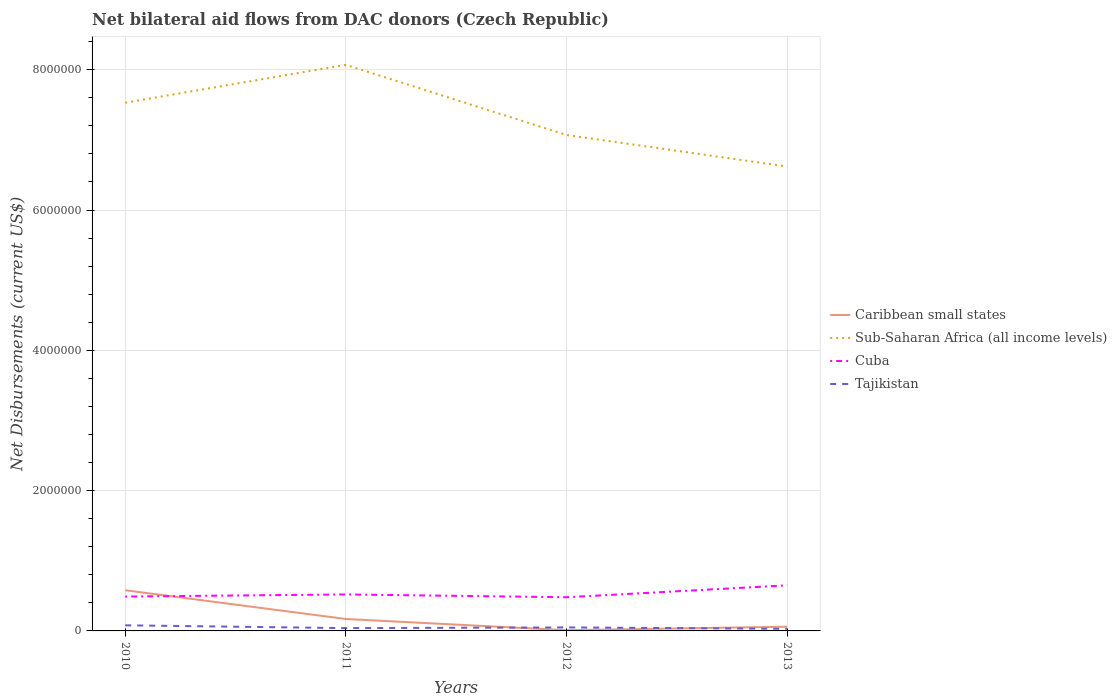Does the line corresponding to Sub-Saharan Africa (all income levels) intersect with the line corresponding to Cuba?
Provide a succinct answer. No. Is the number of lines equal to the number of legend labels?
Give a very brief answer. Yes. Across all years, what is the maximum net bilateral aid flows in Cuba?
Your answer should be very brief. 4.80e+05. What is the total net bilateral aid flows in Cuba in the graph?
Provide a short and direct response. -1.30e+05. What is the difference between the highest and the second highest net bilateral aid flows in Cuba?
Your response must be concise. 1.70e+05. Is the net bilateral aid flows in Cuba strictly greater than the net bilateral aid flows in Sub-Saharan Africa (all income levels) over the years?
Offer a terse response. Yes. Does the graph contain any zero values?
Keep it short and to the point. No. How are the legend labels stacked?
Make the answer very short. Vertical. What is the title of the graph?
Offer a very short reply. Net bilateral aid flows from DAC donors (Czech Republic). What is the label or title of the Y-axis?
Make the answer very short. Net Disbursements (current US$). What is the Net Disbursements (current US$) of Caribbean small states in 2010?
Keep it short and to the point. 5.80e+05. What is the Net Disbursements (current US$) of Sub-Saharan Africa (all income levels) in 2010?
Your response must be concise. 7.53e+06. What is the Net Disbursements (current US$) in Tajikistan in 2010?
Give a very brief answer. 8.00e+04. What is the Net Disbursements (current US$) in Caribbean small states in 2011?
Give a very brief answer. 1.70e+05. What is the Net Disbursements (current US$) of Sub-Saharan Africa (all income levels) in 2011?
Ensure brevity in your answer.  8.07e+06. What is the Net Disbursements (current US$) in Cuba in 2011?
Offer a terse response. 5.20e+05. What is the Net Disbursements (current US$) in Sub-Saharan Africa (all income levels) in 2012?
Offer a terse response. 7.07e+06. What is the Net Disbursements (current US$) in Cuba in 2012?
Provide a short and direct response. 4.80e+05. What is the Net Disbursements (current US$) in Tajikistan in 2012?
Give a very brief answer. 5.00e+04. What is the Net Disbursements (current US$) of Sub-Saharan Africa (all income levels) in 2013?
Provide a short and direct response. 6.62e+06. What is the Net Disbursements (current US$) of Cuba in 2013?
Give a very brief answer. 6.50e+05. What is the Net Disbursements (current US$) of Tajikistan in 2013?
Make the answer very short. 3.00e+04. Across all years, what is the maximum Net Disbursements (current US$) in Caribbean small states?
Make the answer very short. 5.80e+05. Across all years, what is the maximum Net Disbursements (current US$) in Sub-Saharan Africa (all income levels)?
Offer a very short reply. 8.07e+06. Across all years, what is the maximum Net Disbursements (current US$) of Cuba?
Offer a terse response. 6.50e+05. Across all years, what is the minimum Net Disbursements (current US$) in Sub-Saharan Africa (all income levels)?
Make the answer very short. 6.62e+06. What is the total Net Disbursements (current US$) of Caribbean small states in the graph?
Provide a short and direct response. 8.20e+05. What is the total Net Disbursements (current US$) of Sub-Saharan Africa (all income levels) in the graph?
Make the answer very short. 2.93e+07. What is the total Net Disbursements (current US$) of Cuba in the graph?
Your answer should be compact. 2.14e+06. What is the total Net Disbursements (current US$) in Tajikistan in the graph?
Your answer should be compact. 2.00e+05. What is the difference between the Net Disbursements (current US$) of Caribbean small states in 2010 and that in 2011?
Provide a short and direct response. 4.10e+05. What is the difference between the Net Disbursements (current US$) in Sub-Saharan Africa (all income levels) in 2010 and that in 2011?
Provide a short and direct response. -5.40e+05. What is the difference between the Net Disbursements (current US$) of Cuba in 2010 and that in 2011?
Offer a very short reply. -3.00e+04. What is the difference between the Net Disbursements (current US$) in Caribbean small states in 2010 and that in 2012?
Provide a short and direct response. 5.70e+05. What is the difference between the Net Disbursements (current US$) of Tajikistan in 2010 and that in 2012?
Your answer should be compact. 3.00e+04. What is the difference between the Net Disbursements (current US$) of Caribbean small states in 2010 and that in 2013?
Your answer should be very brief. 5.20e+05. What is the difference between the Net Disbursements (current US$) in Sub-Saharan Africa (all income levels) in 2010 and that in 2013?
Make the answer very short. 9.10e+05. What is the difference between the Net Disbursements (current US$) of Caribbean small states in 2011 and that in 2013?
Your answer should be compact. 1.10e+05. What is the difference between the Net Disbursements (current US$) of Sub-Saharan Africa (all income levels) in 2011 and that in 2013?
Offer a very short reply. 1.45e+06. What is the difference between the Net Disbursements (current US$) of Cuba in 2011 and that in 2013?
Give a very brief answer. -1.30e+05. What is the difference between the Net Disbursements (current US$) in Tajikistan in 2011 and that in 2013?
Your response must be concise. 10000. What is the difference between the Net Disbursements (current US$) of Caribbean small states in 2012 and that in 2013?
Provide a short and direct response. -5.00e+04. What is the difference between the Net Disbursements (current US$) in Sub-Saharan Africa (all income levels) in 2012 and that in 2013?
Ensure brevity in your answer.  4.50e+05. What is the difference between the Net Disbursements (current US$) in Cuba in 2012 and that in 2013?
Provide a short and direct response. -1.70e+05. What is the difference between the Net Disbursements (current US$) in Tajikistan in 2012 and that in 2013?
Provide a succinct answer. 2.00e+04. What is the difference between the Net Disbursements (current US$) of Caribbean small states in 2010 and the Net Disbursements (current US$) of Sub-Saharan Africa (all income levels) in 2011?
Ensure brevity in your answer.  -7.49e+06. What is the difference between the Net Disbursements (current US$) of Caribbean small states in 2010 and the Net Disbursements (current US$) of Cuba in 2011?
Your answer should be compact. 6.00e+04. What is the difference between the Net Disbursements (current US$) in Caribbean small states in 2010 and the Net Disbursements (current US$) in Tajikistan in 2011?
Ensure brevity in your answer.  5.40e+05. What is the difference between the Net Disbursements (current US$) of Sub-Saharan Africa (all income levels) in 2010 and the Net Disbursements (current US$) of Cuba in 2011?
Offer a terse response. 7.01e+06. What is the difference between the Net Disbursements (current US$) in Sub-Saharan Africa (all income levels) in 2010 and the Net Disbursements (current US$) in Tajikistan in 2011?
Provide a short and direct response. 7.49e+06. What is the difference between the Net Disbursements (current US$) of Caribbean small states in 2010 and the Net Disbursements (current US$) of Sub-Saharan Africa (all income levels) in 2012?
Offer a terse response. -6.49e+06. What is the difference between the Net Disbursements (current US$) in Caribbean small states in 2010 and the Net Disbursements (current US$) in Cuba in 2012?
Make the answer very short. 1.00e+05. What is the difference between the Net Disbursements (current US$) of Caribbean small states in 2010 and the Net Disbursements (current US$) of Tajikistan in 2012?
Your answer should be very brief. 5.30e+05. What is the difference between the Net Disbursements (current US$) of Sub-Saharan Africa (all income levels) in 2010 and the Net Disbursements (current US$) of Cuba in 2012?
Keep it short and to the point. 7.05e+06. What is the difference between the Net Disbursements (current US$) in Sub-Saharan Africa (all income levels) in 2010 and the Net Disbursements (current US$) in Tajikistan in 2012?
Give a very brief answer. 7.48e+06. What is the difference between the Net Disbursements (current US$) in Cuba in 2010 and the Net Disbursements (current US$) in Tajikistan in 2012?
Ensure brevity in your answer.  4.40e+05. What is the difference between the Net Disbursements (current US$) in Caribbean small states in 2010 and the Net Disbursements (current US$) in Sub-Saharan Africa (all income levels) in 2013?
Provide a short and direct response. -6.04e+06. What is the difference between the Net Disbursements (current US$) in Caribbean small states in 2010 and the Net Disbursements (current US$) in Cuba in 2013?
Your answer should be very brief. -7.00e+04. What is the difference between the Net Disbursements (current US$) of Sub-Saharan Africa (all income levels) in 2010 and the Net Disbursements (current US$) of Cuba in 2013?
Ensure brevity in your answer.  6.88e+06. What is the difference between the Net Disbursements (current US$) of Sub-Saharan Africa (all income levels) in 2010 and the Net Disbursements (current US$) of Tajikistan in 2013?
Make the answer very short. 7.50e+06. What is the difference between the Net Disbursements (current US$) in Caribbean small states in 2011 and the Net Disbursements (current US$) in Sub-Saharan Africa (all income levels) in 2012?
Your answer should be very brief. -6.90e+06. What is the difference between the Net Disbursements (current US$) of Caribbean small states in 2011 and the Net Disbursements (current US$) of Cuba in 2012?
Offer a very short reply. -3.10e+05. What is the difference between the Net Disbursements (current US$) of Caribbean small states in 2011 and the Net Disbursements (current US$) of Tajikistan in 2012?
Give a very brief answer. 1.20e+05. What is the difference between the Net Disbursements (current US$) in Sub-Saharan Africa (all income levels) in 2011 and the Net Disbursements (current US$) in Cuba in 2012?
Make the answer very short. 7.59e+06. What is the difference between the Net Disbursements (current US$) in Sub-Saharan Africa (all income levels) in 2011 and the Net Disbursements (current US$) in Tajikistan in 2012?
Offer a very short reply. 8.02e+06. What is the difference between the Net Disbursements (current US$) in Cuba in 2011 and the Net Disbursements (current US$) in Tajikistan in 2012?
Keep it short and to the point. 4.70e+05. What is the difference between the Net Disbursements (current US$) of Caribbean small states in 2011 and the Net Disbursements (current US$) of Sub-Saharan Africa (all income levels) in 2013?
Make the answer very short. -6.45e+06. What is the difference between the Net Disbursements (current US$) in Caribbean small states in 2011 and the Net Disbursements (current US$) in Cuba in 2013?
Make the answer very short. -4.80e+05. What is the difference between the Net Disbursements (current US$) of Sub-Saharan Africa (all income levels) in 2011 and the Net Disbursements (current US$) of Cuba in 2013?
Offer a terse response. 7.42e+06. What is the difference between the Net Disbursements (current US$) in Sub-Saharan Africa (all income levels) in 2011 and the Net Disbursements (current US$) in Tajikistan in 2013?
Ensure brevity in your answer.  8.04e+06. What is the difference between the Net Disbursements (current US$) in Cuba in 2011 and the Net Disbursements (current US$) in Tajikistan in 2013?
Offer a terse response. 4.90e+05. What is the difference between the Net Disbursements (current US$) of Caribbean small states in 2012 and the Net Disbursements (current US$) of Sub-Saharan Africa (all income levels) in 2013?
Provide a succinct answer. -6.61e+06. What is the difference between the Net Disbursements (current US$) in Caribbean small states in 2012 and the Net Disbursements (current US$) in Cuba in 2013?
Ensure brevity in your answer.  -6.40e+05. What is the difference between the Net Disbursements (current US$) in Caribbean small states in 2012 and the Net Disbursements (current US$) in Tajikistan in 2013?
Your answer should be very brief. -2.00e+04. What is the difference between the Net Disbursements (current US$) in Sub-Saharan Africa (all income levels) in 2012 and the Net Disbursements (current US$) in Cuba in 2013?
Keep it short and to the point. 6.42e+06. What is the difference between the Net Disbursements (current US$) of Sub-Saharan Africa (all income levels) in 2012 and the Net Disbursements (current US$) of Tajikistan in 2013?
Offer a terse response. 7.04e+06. What is the difference between the Net Disbursements (current US$) of Cuba in 2012 and the Net Disbursements (current US$) of Tajikistan in 2013?
Provide a short and direct response. 4.50e+05. What is the average Net Disbursements (current US$) in Caribbean small states per year?
Ensure brevity in your answer.  2.05e+05. What is the average Net Disbursements (current US$) of Sub-Saharan Africa (all income levels) per year?
Your answer should be compact. 7.32e+06. What is the average Net Disbursements (current US$) of Cuba per year?
Keep it short and to the point. 5.35e+05. In the year 2010, what is the difference between the Net Disbursements (current US$) of Caribbean small states and Net Disbursements (current US$) of Sub-Saharan Africa (all income levels)?
Your response must be concise. -6.95e+06. In the year 2010, what is the difference between the Net Disbursements (current US$) in Caribbean small states and Net Disbursements (current US$) in Tajikistan?
Ensure brevity in your answer.  5.00e+05. In the year 2010, what is the difference between the Net Disbursements (current US$) in Sub-Saharan Africa (all income levels) and Net Disbursements (current US$) in Cuba?
Your response must be concise. 7.04e+06. In the year 2010, what is the difference between the Net Disbursements (current US$) in Sub-Saharan Africa (all income levels) and Net Disbursements (current US$) in Tajikistan?
Give a very brief answer. 7.45e+06. In the year 2011, what is the difference between the Net Disbursements (current US$) in Caribbean small states and Net Disbursements (current US$) in Sub-Saharan Africa (all income levels)?
Offer a very short reply. -7.90e+06. In the year 2011, what is the difference between the Net Disbursements (current US$) in Caribbean small states and Net Disbursements (current US$) in Cuba?
Keep it short and to the point. -3.50e+05. In the year 2011, what is the difference between the Net Disbursements (current US$) in Caribbean small states and Net Disbursements (current US$) in Tajikistan?
Your answer should be very brief. 1.30e+05. In the year 2011, what is the difference between the Net Disbursements (current US$) in Sub-Saharan Africa (all income levels) and Net Disbursements (current US$) in Cuba?
Ensure brevity in your answer.  7.55e+06. In the year 2011, what is the difference between the Net Disbursements (current US$) in Sub-Saharan Africa (all income levels) and Net Disbursements (current US$) in Tajikistan?
Make the answer very short. 8.03e+06. In the year 2012, what is the difference between the Net Disbursements (current US$) in Caribbean small states and Net Disbursements (current US$) in Sub-Saharan Africa (all income levels)?
Your answer should be compact. -7.06e+06. In the year 2012, what is the difference between the Net Disbursements (current US$) in Caribbean small states and Net Disbursements (current US$) in Cuba?
Ensure brevity in your answer.  -4.70e+05. In the year 2012, what is the difference between the Net Disbursements (current US$) of Caribbean small states and Net Disbursements (current US$) of Tajikistan?
Provide a succinct answer. -4.00e+04. In the year 2012, what is the difference between the Net Disbursements (current US$) of Sub-Saharan Africa (all income levels) and Net Disbursements (current US$) of Cuba?
Your response must be concise. 6.59e+06. In the year 2012, what is the difference between the Net Disbursements (current US$) in Sub-Saharan Africa (all income levels) and Net Disbursements (current US$) in Tajikistan?
Keep it short and to the point. 7.02e+06. In the year 2012, what is the difference between the Net Disbursements (current US$) of Cuba and Net Disbursements (current US$) of Tajikistan?
Offer a very short reply. 4.30e+05. In the year 2013, what is the difference between the Net Disbursements (current US$) of Caribbean small states and Net Disbursements (current US$) of Sub-Saharan Africa (all income levels)?
Provide a short and direct response. -6.56e+06. In the year 2013, what is the difference between the Net Disbursements (current US$) of Caribbean small states and Net Disbursements (current US$) of Cuba?
Your answer should be compact. -5.90e+05. In the year 2013, what is the difference between the Net Disbursements (current US$) in Sub-Saharan Africa (all income levels) and Net Disbursements (current US$) in Cuba?
Provide a succinct answer. 5.97e+06. In the year 2013, what is the difference between the Net Disbursements (current US$) of Sub-Saharan Africa (all income levels) and Net Disbursements (current US$) of Tajikistan?
Your answer should be compact. 6.59e+06. In the year 2013, what is the difference between the Net Disbursements (current US$) in Cuba and Net Disbursements (current US$) in Tajikistan?
Your response must be concise. 6.20e+05. What is the ratio of the Net Disbursements (current US$) in Caribbean small states in 2010 to that in 2011?
Your response must be concise. 3.41. What is the ratio of the Net Disbursements (current US$) in Sub-Saharan Africa (all income levels) in 2010 to that in 2011?
Keep it short and to the point. 0.93. What is the ratio of the Net Disbursements (current US$) in Cuba in 2010 to that in 2011?
Keep it short and to the point. 0.94. What is the ratio of the Net Disbursements (current US$) of Tajikistan in 2010 to that in 2011?
Your response must be concise. 2. What is the ratio of the Net Disbursements (current US$) in Caribbean small states in 2010 to that in 2012?
Make the answer very short. 58. What is the ratio of the Net Disbursements (current US$) of Sub-Saharan Africa (all income levels) in 2010 to that in 2012?
Provide a succinct answer. 1.07. What is the ratio of the Net Disbursements (current US$) of Cuba in 2010 to that in 2012?
Make the answer very short. 1.02. What is the ratio of the Net Disbursements (current US$) in Caribbean small states in 2010 to that in 2013?
Make the answer very short. 9.67. What is the ratio of the Net Disbursements (current US$) of Sub-Saharan Africa (all income levels) in 2010 to that in 2013?
Your answer should be compact. 1.14. What is the ratio of the Net Disbursements (current US$) of Cuba in 2010 to that in 2013?
Ensure brevity in your answer.  0.75. What is the ratio of the Net Disbursements (current US$) in Tajikistan in 2010 to that in 2013?
Your answer should be compact. 2.67. What is the ratio of the Net Disbursements (current US$) in Sub-Saharan Africa (all income levels) in 2011 to that in 2012?
Give a very brief answer. 1.14. What is the ratio of the Net Disbursements (current US$) in Cuba in 2011 to that in 2012?
Offer a very short reply. 1.08. What is the ratio of the Net Disbursements (current US$) of Caribbean small states in 2011 to that in 2013?
Provide a succinct answer. 2.83. What is the ratio of the Net Disbursements (current US$) in Sub-Saharan Africa (all income levels) in 2011 to that in 2013?
Your response must be concise. 1.22. What is the ratio of the Net Disbursements (current US$) of Cuba in 2011 to that in 2013?
Offer a very short reply. 0.8. What is the ratio of the Net Disbursements (current US$) in Tajikistan in 2011 to that in 2013?
Give a very brief answer. 1.33. What is the ratio of the Net Disbursements (current US$) of Sub-Saharan Africa (all income levels) in 2012 to that in 2013?
Your response must be concise. 1.07. What is the ratio of the Net Disbursements (current US$) in Cuba in 2012 to that in 2013?
Keep it short and to the point. 0.74. What is the difference between the highest and the second highest Net Disbursements (current US$) in Caribbean small states?
Provide a succinct answer. 4.10e+05. What is the difference between the highest and the second highest Net Disbursements (current US$) in Sub-Saharan Africa (all income levels)?
Ensure brevity in your answer.  5.40e+05. What is the difference between the highest and the second highest Net Disbursements (current US$) in Cuba?
Offer a very short reply. 1.30e+05. What is the difference between the highest and the second highest Net Disbursements (current US$) of Tajikistan?
Offer a terse response. 3.00e+04. What is the difference between the highest and the lowest Net Disbursements (current US$) of Caribbean small states?
Provide a succinct answer. 5.70e+05. What is the difference between the highest and the lowest Net Disbursements (current US$) in Sub-Saharan Africa (all income levels)?
Ensure brevity in your answer.  1.45e+06. What is the difference between the highest and the lowest Net Disbursements (current US$) of Cuba?
Offer a terse response. 1.70e+05. What is the difference between the highest and the lowest Net Disbursements (current US$) of Tajikistan?
Your response must be concise. 5.00e+04. 